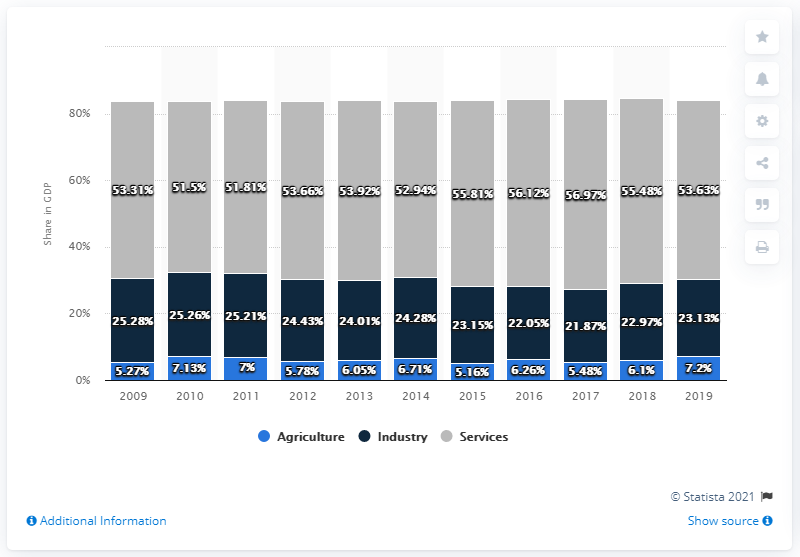List a handful of essential elements in this visual. In 2019, the agriculture sector accounted for 7.2% of Argentina's gross domestic product. 